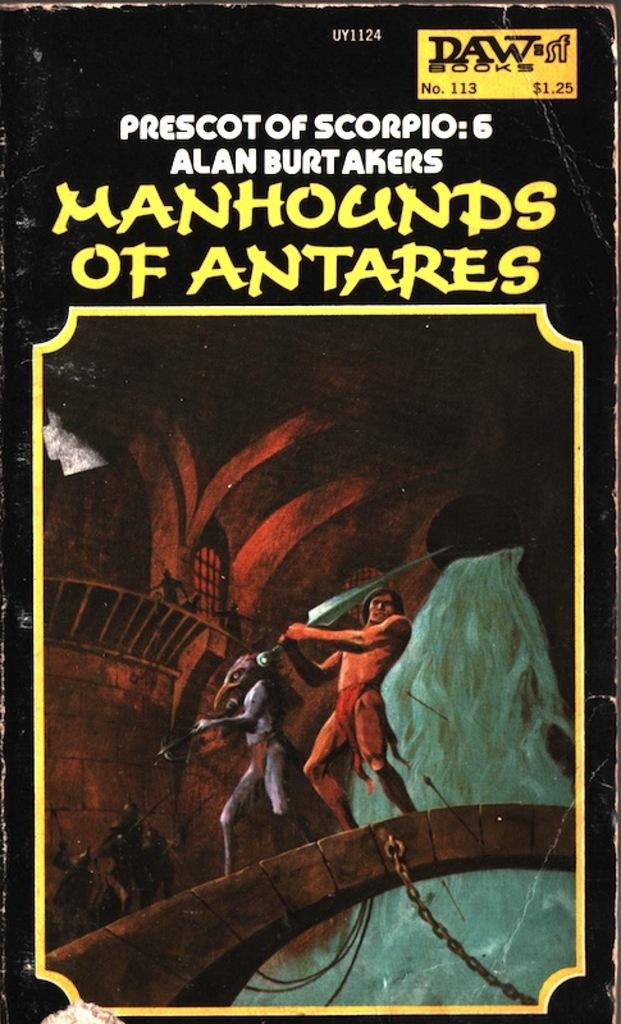What is the title of the book?
Offer a terse response. Manhounds of antares. 